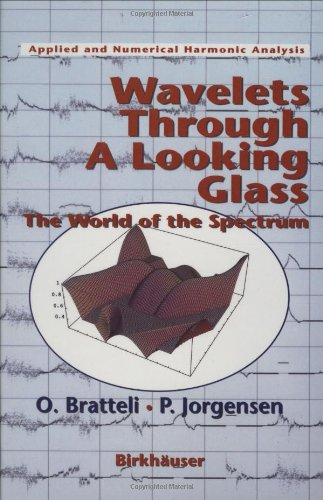Who wrote this book?
Answer the question using a single word or phrase. Ola Bratteli What is the title of this book? Wavelets Through a Looking Glass: The World of the Spectrum (Applied and Numerical Harmonic Analysis) What type of book is this? Computers & Technology Is this a digital technology book? Yes Is this a religious book? No 